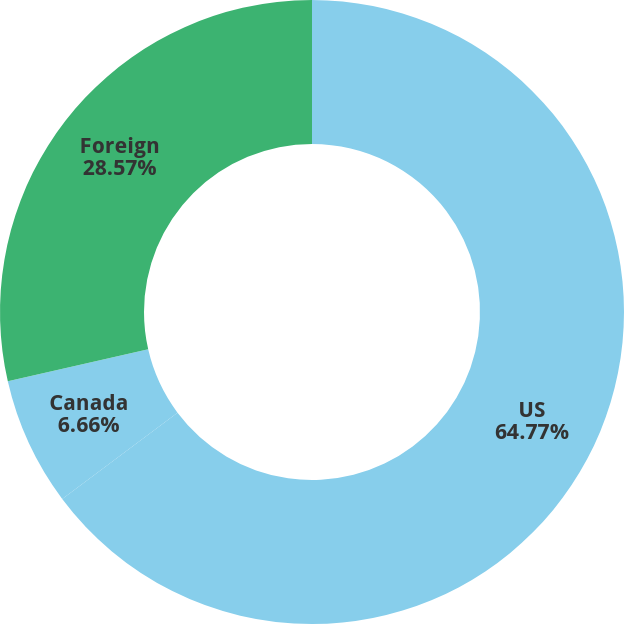<chart> <loc_0><loc_0><loc_500><loc_500><pie_chart><fcel>US<fcel>Canada<fcel>Foreign<nl><fcel>64.78%<fcel>6.66%<fcel>28.57%<nl></chart> 